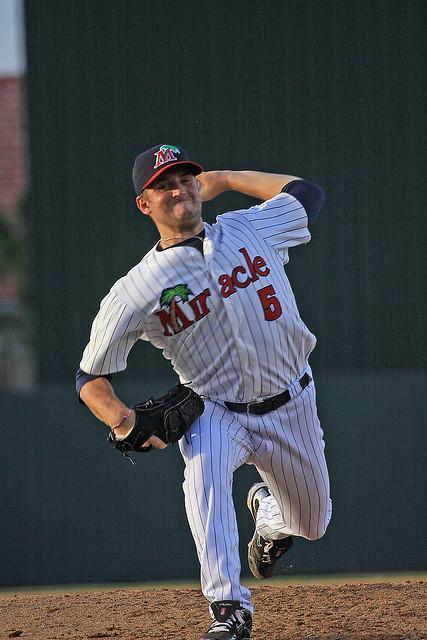How many bananas are bruised?
Give a very brief answer. 0. 